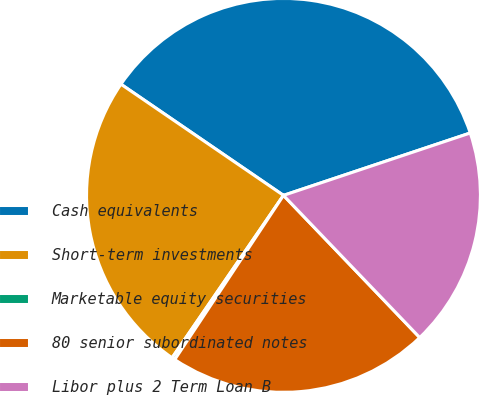Convert chart to OTSL. <chart><loc_0><loc_0><loc_500><loc_500><pie_chart><fcel>Cash equivalents<fcel>Short-term investments<fcel>Marketable equity securities<fcel>80 senior subordinated notes<fcel>Libor plus 2 Term Loan B<nl><fcel>35.32%<fcel>24.98%<fcel>0.26%<fcel>21.47%<fcel>17.97%<nl></chart> 